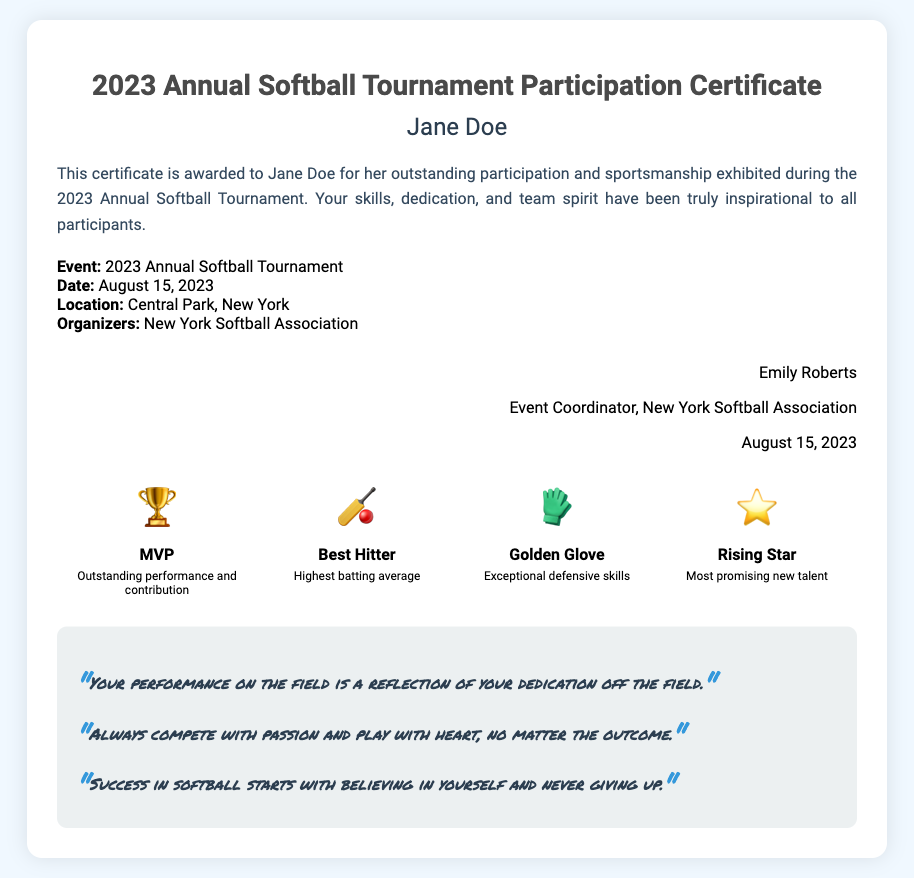What is the title of the document? The title is typically found in the header section of the document, which is "2023 Annual Softball Tournament Participation Certificate."
Answer: 2023 Annual Softball Tournament Participation Certificate Who received the certificate? The recipient's name is usually displayed prominently in the document, which is "Jane Doe."
Answer: Jane Doe What is the date of the tournament? The date is specified in the event details portion of the document, which indicates when the event took place.
Answer: August 15, 2023 Where was the tournament held? The location is outlined in the event details and indicates where the tournament took place.
Answer: Central Park, New York What badge is awarded for "Outstanding performance and contribution"? This information can be found in the badges section, detailing what each badge represents.
Answer: MVP How many badges are listed in the document? The number of badges can be counted in the badges section, indicating the different recognitions available.
Answer: 4 What is one of Janae Jefferson's quotes mentioned? The quotes are listed under a specific section in the document, sharing inspirational messages related to softball.
Answer: Your performance on the field is a reflection of your dedication off the field Who is the event coordinator? The signature section of the document provides details about the individual overseeing the event, including their name and title.
Answer: Emily Roberts What does the "Golden Glove" badge signify? The description section of the badge details what each represents, indicating the skill recognized.
Answer: Exceptional defensive skills 